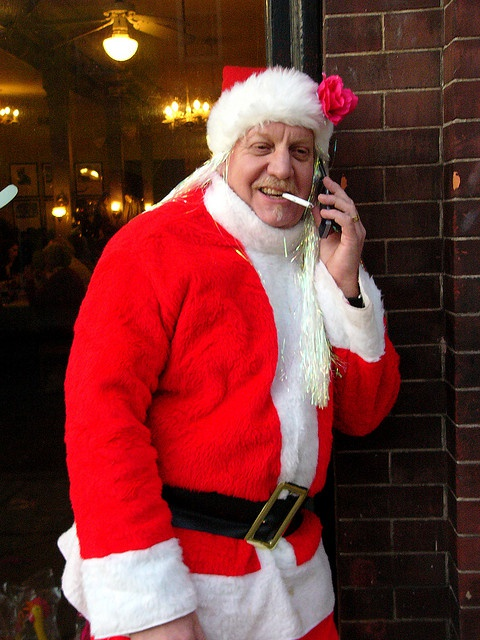Describe the objects in this image and their specific colors. I can see people in maroon, red, lightgray, brown, and darkgray tones, people in maroon, black, red, and brown tones, people in black and maroon tones, and cell phone in maroon, black, gray, and brown tones in this image. 